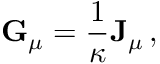Convert formula to latex. <formula><loc_0><loc_0><loc_500><loc_500>{ G } _ { \mu } = { \frac { 1 } { \kappa } } { J } _ { \mu } \, ,</formula> 